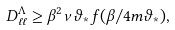<formula> <loc_0><loc_0><loc_500><loc_500>D ^ { \Lambda } _ { \ell \ell } \geq \beta ^ { 2 } \nu \vartheta _ { * } f ( \beta / 4 m \vartheta _ { * } ) ,</formula> 